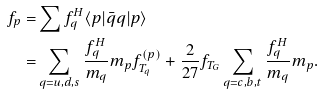<formula> <loc_0><loc_0><loc_500><loc_500>f _ { p } = & \sum f _ { q } ^ { H } \langle p | \bar { q } q | p \rangle \\ = & \sum _ { q = u , d , s } \frac { f _ { q } ^ { H } } { m _ { q } } m _ { p } f _ { T _ { q } } ^ { ( p ) } + \frac { 2 } { 2 7 } f _ { T _ { G } } \sum _ { q = c , b , t } \frac { f _ { q } ^ { H } } { m _ { q } } m _ { p } .</formula> 